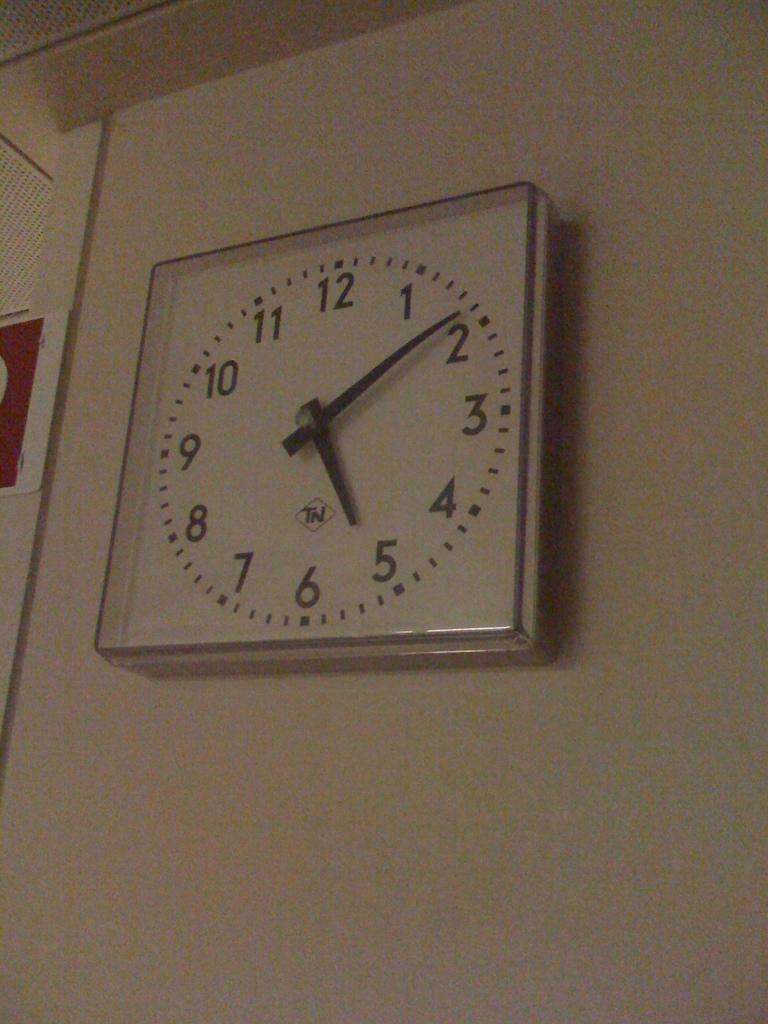What number is the little hand pointing to?
Ensure brevity in your answer.  5. 